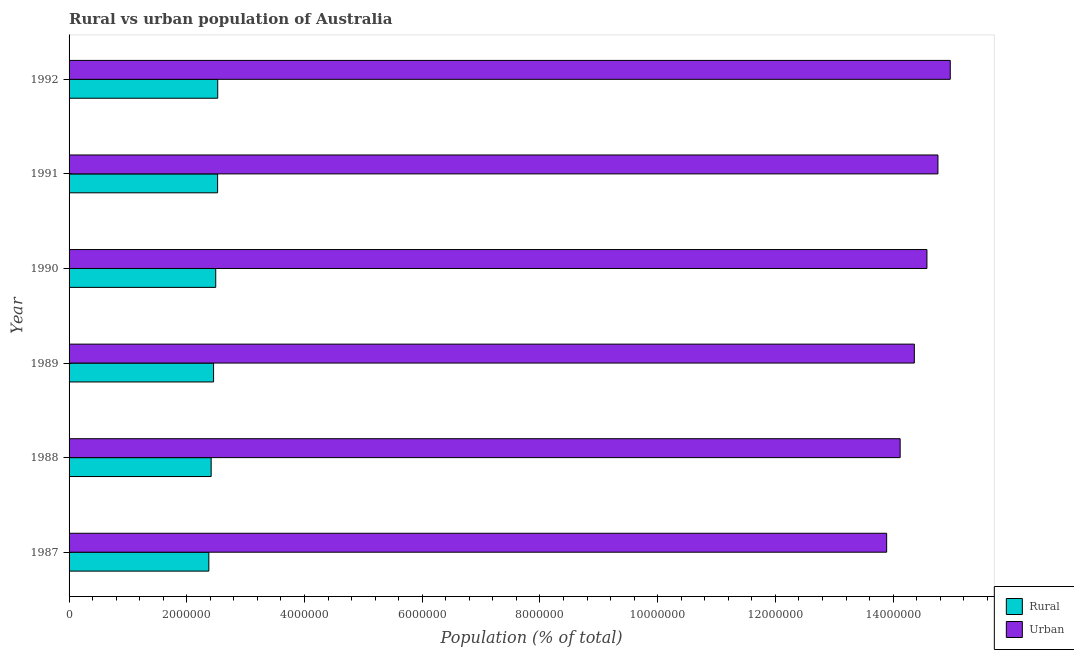How many different coloured bars are there?
Make the answer very short. 2. How many groups of bars are there?
Your answer should be very brief. 6. Are the number of bars on each tick of the Y-axis equal?
Provide a succinct answer. Yes. How many bars are there on the 5th tick from the top?
Your response must be concise. 2. In how many cases, is the number of bars for a given year not equal to the number of legend labels?
Your answer should be compact. 0. What is the urban population density in 1991?
Offer a terse response. 1.48e+07. Across all years, what is the maximum rural population density?
Your answer should be very brief. 2.53e+06. Across all years, what is the minimum rural population density?
Provide a short and direct response. 2.37e+06. In which year was the urban population density maximum?
Provide a succinct answer. 1992. In which year was the rural population density minimum?
Offer a very short reply. 1987. What is the total urban population density in the graph?
Give a very brief answer. 8.67e+07. What is the difference between the urban population density in 1987 and that in 1988?
Your answer should be very brief. -2.29e+05. What is the difference between the urban population density in 1989 and the rural population density in 1988?
Offer a very short reply. 1.19e+07. What is the average urban population density per year?
Your answer should be very brief. 1.44e+07. In the year 1987, what is the difference between the urban population density and rural population density?
Give a very brief answer. 1.15e+07. Is the difference between the urban population density in 1987 and 1989 greater than the difference between the rural population density in 1987 and 1989?
Make the answer very short. No. What is the difference between the highest and the second highest urban population density?
Offer a very short reply. 2.09e+05. What is the difference between the highest and the lowest urban population density?
Ensure brevity in your answer.  1.08e+06. In how many years, is the urban population density greater than the average urban population density taken over all years?
Your answer should be compact. 3. Is the sum of the urban population density in 1989 and 1991 greater than the maximum rural population density across all years?
Provide a succinct answer. Yes. What does the 1st bar from the top in 1989 represents?
Offer a terse response. Urban. What does the 2nd bar from the bottom in 1989 represents?
Offer a very short reply. Urban. Are all the bars in the graph horizontal?
Provide a succinct answer. Yes. How many years are there in the graph?
Offer a very short reply. 6. Are the values on the major ticks of X-axis written in scientific E-notation?
Provide a succinct answer. No. Does the graph contain grids?
Your response must be concise. No. How many legend labels are there?
Your response must be concise. 2. What is the title of the graph?
Provide a succinct answer. Rural vs urban population of Australia. What is the label or title of the X-axis?
Your response must be concise. Population (% of total). What is the Population (% of total) of Rural in 1987?
Offer a terse response. 2.37e+06. What is the Population (% of total) of Urban in 1987?
Your response must be concise. 1.39e+07. What is the Population (% of total) in Rural in 1988?
Provide a succinct answer. 2.41e+06. What is the Population (% of total) of Urban in 1988?
Offer a very short reply. 1.41e+07. What is the Population (% of total) in Rural in 1989?
Give a very brief answer. 2.45e+06. What is the Population (% of total) of Urban in 1989?
Your answer should be compact. 1.44e+07. What is the Population (% of total) in Rural in 1990?
Your answer should be very brief. 2.49e+06. What is the Population (% of total) in Urban in 1990?
Keep it short and to the point. 1.46e+07. What is the Population (% of total) of Rural in 1991?
Provide a succinct answer. 2.52e+06. What is the Population (% of total) of Urban in 1991?
Keep it short and to the point. 1.48e+07. What is the Population (% of total) in Rural in 1992?
Your response must be concise. 2.53e+06. What is the Population (% of total) in Urban in 1992?
Offer a very short reply. 1.50e+07. Across all years, what is the maximum Population (% of total) in Rural?
Provide a succinct answer. 2.53e+06. Across all years, what is the maximum Population (% of total) of Urban?
Your answer should be compact. 1.50e+07. Across all years, what is the minimum Population (% of total) in Rural?
Provide a short and direct response. 2.37e+06. Across all years, what is the minimum Population (% of total) of Urban?
Your response must be concise. 1.39e+07. What is the total Population (% of total) in Rural in the graph?
Provide a short and direct response. 1.48e+07. What is the total Population (% of total) in Urban in the graph?
Offer a terse response. 8.67e+07. What is the difference between the Population (% of total) of Rural in 1987 and that in 1988?
Provide a succinct answer. -3.92e+04. What is the difference between the Population (% of total) of Urban in 1987 and that in 1988?
Keep it short and to the point. -2.29e+05. What is the difference between the Population (% of total) in Rural in 1987 and that in 1989?
Offer a terse response. -8.04e+04. What is the difference between the Population (% of total) of Urban in 1987 and that in 1989?
Your response must be concise. -4.70e+05. What is the difference between the Population (% of total) in Rural in 1987 and that in 1990?
Provide a short and direct response. -1.17e+05. What is the difference between the Population (% of total) of Urban in 1987 and that in 1990?
Ensure brevity in your answer.  -6.84e+05. What is the difference between the Population (% of total) in Rural in 1987 and that in 1991?
Provide a short and direct response. -1.49e+05. What is the difference between the Population (% of total) of Urban in 1987 and that in 1991?
Your answer should be very brief. -8.71e+05. What is the difference between the Population (% of total) in Rural in 1987 and that in 1992?
Your answer should be compact. -1.51e+05. What is the difference between the Population (% of total) in Urban in 1987 and that in 1992?
Make the answer very short. -1.08e+06. What is the difference between the Population (% of total) in Rural in 1988 and that in 1989?
Keep it short and to the point. -4.12e+04. What is the difference between the Population (% of total) of Urban in 1988 and that in 1989?
Provide a short and direct response. -2.41e+05. What is the difference between the Population (% of total) in Rural in 1988 and that in 1990?
Make the answer very short. -7.78e+04. What is the difference between the Population (% of total) in Urban in 1988 and that in 1990?
Make the answer very short. -4.55e+05. What is the difference between the Population (% of total) of Rural in 1988 and that in 1991?
Provide a short and direct response. -1.10e+05. What is the difference between the Population (% of total) of Urban in 1988 and that in 1991?
Provide a short and direct response. -6.42e+05. What is the difference between the Population (% of total) of Rural in 1988 and that in 1992?
Your answer should be very brief. -1.12e+05. What is the difference between the Population (% of total) of Urban in 1988 and that in 1992?
Offer a terse response. -8.51e+05. What is the difference between the Population (% of total) in Rural in 1989 and that in 1990?
Make the answer very short. -3.66e+04. What is the difference between the Population (% of total) in Urban in 1989 and that in 1990?
Provide a succinct answer. -2.14e+05. What is the difference between the Population (% of total) in Rural in 1989 and that in 1991?
Your response must be concise. -6.86e+04. What is the difference between the Population (% of total) of Urban in 1989 and that in 1991?
Provide a succinct answer. -4.01e+05. What is the difference between the Population (% of total) of Rural in 1989 and that in 1992?
Your response must be concise. -7.03e+04. What is the difference between the Population (% of total) of Urban in 1989 and that in 1992?
Provide a succinct answer. -6.10e+05. What is the difference between the Population (% of total) of Rural in 1990 and that in 1991?
Your response must be concise. -3.20e+04. What is the difference between the Population (% of total) in Urban in 1990 and that in 1991?
Offer a very short reply. -1.87e+05. What is the difference between the Population (% of total) in Rural in 1990 and that in 1992?
Offer a very short reply. -3.37e+04. What is the difference between the Population (% of total) in Urban in 1990 and that in 1992?
Your answer should be very brief. -3.96e+05. What is the difference between the Population (% of total) in Rural in 1991 and that in 1992?
Give a very brief answer. -1764. What is the difference between the Population (% of total) in Urban in 1991 and that in 1992?
Your answer should be compact. -2.09e+05. What is the difference between the Population (% of total) of Rural in 1987 and the Population (% of total) of Urban in 1988?
Offer a terse response. -1.17e+07. What is the difference between the Population (% of total) of Rural in 1987 and the Population (% of total) of Urban in 1989?
Ensure brevity in your answer.  -1.20e+07. What is the difference between the Population (% of total) of Rural in 1987 and the Population (% of total) of Urban in 1990?
Your answer should be compact. -1.22e+07. What is the difference between the Population (% of total) of Rural in 1987 and the Population (% of total) of Urban in 1991?
Keep it short and to the point. -1.24e+07. What is the difference between the Population (% of total) of Rural in 1987 and the Population (% of total) of Urban in 1992?
Provide a succinct answer. -1.26e+07. What is the difference between the Population (% of total) of Rural in 1988 and the Population (% of total) of Urban in 1989?
Provide a succinct answer. -1.19e+07. What is the difference between the Population (% of total) of Rural in 1988 and the Population (% of total) of Urban in 1990?
Provide a succinct answer. -1.22e+07. What is the difference between the Population (% of total) in Rural in 1988 and the Population (% of total) in Urban in 1991?
Provide a short and direct response. -1.23e+07. What is the difference between the Population (% of total) of Rural in 1988 and the Population (% of total) of Urban in 1992?
Keep it short and to the point. -1.26e+07. What is the difference between the Population (% of total) in Rural in 1989 and the Population (% of total) in Urban in 1990?
Ensure brevity in your answer.  -1.21e+07. What is the difference between the Population (% of total) of Rural in 1989 and the Population (% of total) of Urban in 1991?
Your answer should be very brief. -1.23e+07. What is the difference between the Population (% of total) in Rural in 1989 and the Population (% of total) in Urban in 1992?
Your answer should be compact. -1.25e+07. What is the difference between the Population (% of total) of Rural in 1990 and the Population (% of total) of Urban in 1991?
Offer a terse response. -1.23e+07. What is the difference between the Population (% of total) in Rural in 1990 and the Population (% of total) in Urban in 1992?
Make the answer very short. -1.25e+07. What is the difference between the Population (% of total) of Rural in 1991 and the Population (% of total) of Urban in 1992?
Offer a terse response. -1.24e+07. What is the average Population (% of total) of Rural per year?
Provide a succinct answer. 2.46e+06. What is the average Population (% of total) of Urban per year?
Offer a very short reply. 1.44e+07. In the year 1987, what is the difference between the Population (% of total) of Rural and Population (% of total) of Urban?
Offer a terse response. -1.15e+07. In the year 1988, what is the difference between the Population (% of total) in Rural and Population (% of total) in Urban?
Offer a very short reply. -1.17e+07. In the year 1989, what is the difference between the Population (% of total) of Rural and Population (% of total) of Urban?
Make the answer very short. -1.19e+07. In the year 1990, what is the difference between the Population (% of total) in Rural and Population (% of total) in Urban?
Provide a short and direct response. -1.21e+07. In the year 1991, what is the difference between the Population (% of total) in Rural and Population (% of total) in Urban?
Ensure brevity in your answer.  -1.22e+07. In the year 1992, what is the difference between the Population (% of total) of Rural and Population (% of total) of Urban?
Offer a very short reply. -1.24e+07. What is the ratio of the Population (% of total) in Rural in 1987 to that in 1988?
Make the answer very short. 0.98. What is the ratio of the Population (% of total) of Urban in 1987 to that in 1988?
Ensure brevity in your answer.  0.98. What is the ratio of the Population (% of total) of Rural in 1987 to that in 1989?
Provide a short and direct response. 0.97. What is the ratio of the Population (% of total) in Urban in 1987 to that in 1989?
Provide a short and direct response. 0.97. What is the ratio of the Population (% of total) in Rural in 1987 to that in 1990?
Your answer should be compact. 0.95. What is the ratio of the Population (% of total) in Urban in 1987 to that in 1990?
Make the answer very short. 0.95. What is the ratio of the Population (% of total) of Rural in 1987 to that in 1991?
Offer a very short reply. 0.94. What is the ratio of the Population (% of total) of Urban in 1987 to that in 1991?
Offer a terse response. 0.94. What is the ratio of the Population (% of total) in Rural in 1987 to that in 1992?
Offer a terse response. 0.94. What is the ratio of the Population (% of total) of Urban in 1987 to that in 1992?
Your response must be concise. 0.93. What is the ratio of the Population (% of total) in Rural in 1988 to that in 1989?
Offer a terse response. 0.98. What is the ratio of the Population (% of total) of Urban in 1988 to that in 1989?
Keep it short and to the point. 0.98. What is the ratio of the Population (% of total) of Rural in 1988 to that in 1990?
Your answer should be very brief. 0.97. What is the ratio of the Population (% of total) in Urban in 1988 to that in 1990?
Ensure brevity in your answer.  0.97. What is the ratio of the Population (% of total) of Rural in 1988 to that in 1991?
Offer a very short reply. 0.96. What is the ratio of the Population (% of total) of Urban in 1988 to that in 1991?
Make the answer very short. 0.96. What is the ratio of the Population (% of total) of Rural in 1988 to that in 1992?
Offer a terse response. 0.96. What is the ratio of the Population (% of total) in Urban in 1988 to that in 1992?
Your response must be concise. 0.94. What is the ratio of the Population (% of total) of Rural in 1989 to that in 1990?
Your answer should be very brief. 0.99. What is the ratio of the Population (% of total) of Rural in 1989 to that in 1991?
Give a very brief answer. 0.97. What is the ratio of the Population (% of total) in Urban in 1989 to that in 1991?
Provide a succinct answer. 0.97. What is the ratio of the Population (% of total) of Rural in 1989 to that in 1992?
Your response must be concise. 0.97. What is the ratio of the Population (% of total) of Urban in 1989 to that in 1992?
Offer a terse response. 0.96. What is the ratio of the Population (% of total) of Rural in 1990 to that in 1991?
Provide a short and direct response. 0.99. What is the ratio of the Population (% of total) of Urban in 1990 to that in 1991?
Keep it short and to the point. 0.99. What is the ratio of the Population (% of total) in Rural in 1990 to that in 1992?
Provide a succinct answer. 0.99. What is the ratio of the Population (% of total) of Urban in 1990 to that in 1992?
Give a very brief answer. 0.97. What is the ratio of the Population (% of total) in Rural in 1991 to that in 1992?
Keep it short and to the point. 1. What is the difference between the highest and the second highest Population (% of total) in Rural?
Keep it short and to the point. 1764. What is the difference between the highest and the second highest Population (% of total) of Urban?
Your response must be concise. 2.09e+05. What is the difference between the highest and the lowest Population (% of total) of Rural?
Your answer should be compact. 1.51e+05. What is the difference between the highest and the lowest Population (% of total) in Urban?
Offer a very short reply. 1.08e+06. 